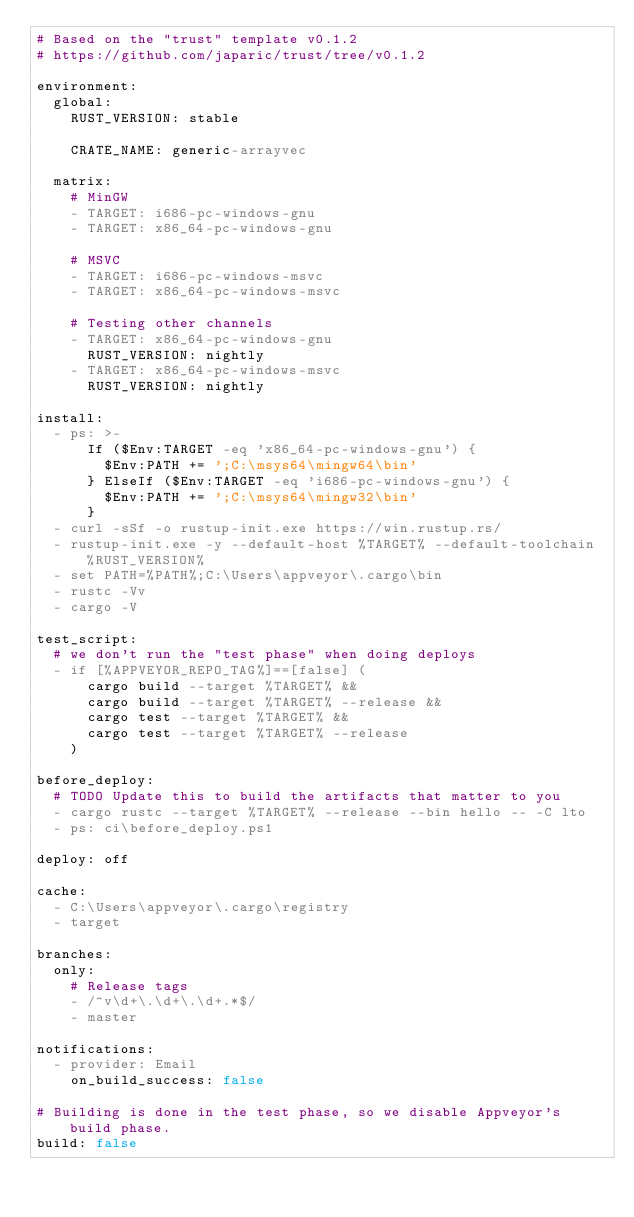Convert code to text. <code><loc_0><loc_0><loc_500><loc_500><_YAML_># Based on the "trust" template v0.1.2
# https://github.com/japaric/trust/tree/v0.1.2

environment:
  global:
    RUST_VERSION: stable

    CRATE_NAME: generic-arrayvec

  matrix:
    # MinGW
    - TARGET: i686-pc-windows-gnu
    - TARGET: x86_64-pc-windows-gnu

    # MSVC
    - TARGET: i686-pc-windows-msvc
    - TARGET: x86_64-pc-windows-msvc

    # Testing other channels
    - TARGET: x86_64-pc-windows-gnu
      RUST_VERSION: nightly
    - TARGET: x86_64-pc-windows-msvc
      RUST_VERSION: nightly

install:
  - ps: >-
      If ($Env:TARGET -eq 'x86_64-pc-windows-gnu') {
        $Env:PATH += ';C:\msys64\mingw64\bin'
      } ElseIf ($Env:TARGET -eq 'i686-pc-windows-gnu') {
        $Env:PATH += ';C:\msys64\mingw32\bin'
      }
  - curl -sSf -o rustup-init.exe https://win.rustup.rs/
  - rustup-init.exe -y --default-host %TARGET% --default-toolchain %RUST_VERSION%
  - set PATH=%PATH%;C:\Users\appveyor\.cargo\bin
  - rustc -Vv
  - cargo -V

test_script:
  # we don't run the "test phase" when doing deploys
  - if [%APPVEYOR_REPO_TAG%]==[false] (
      cargo build --target %TARGET% &&
      cargo build --target %TARGET% --release &&
      cargo test --target %TARGET% &&
      cargo test --target %TARGET% --release
    )

before_deploy:
  # TODO Update this to build the artifacts that matter to you
  - cargo rustc --target %TARGET% --release --bin hello -- -C lto
  - ps: ci\before_deploy.ps1

deploy: off

cache:
  - C:\Users\appveyor\.cargo\registry
  - target

branches:
  only:
    # Release tags
    - /^v\d+\.\d+\.\d+.*$/
    - master

notifications:
  - provider: Email
    on_build_success: false

# Building is done in the test phase, so we disable Appveyor's build phase.
build: false
</code> 